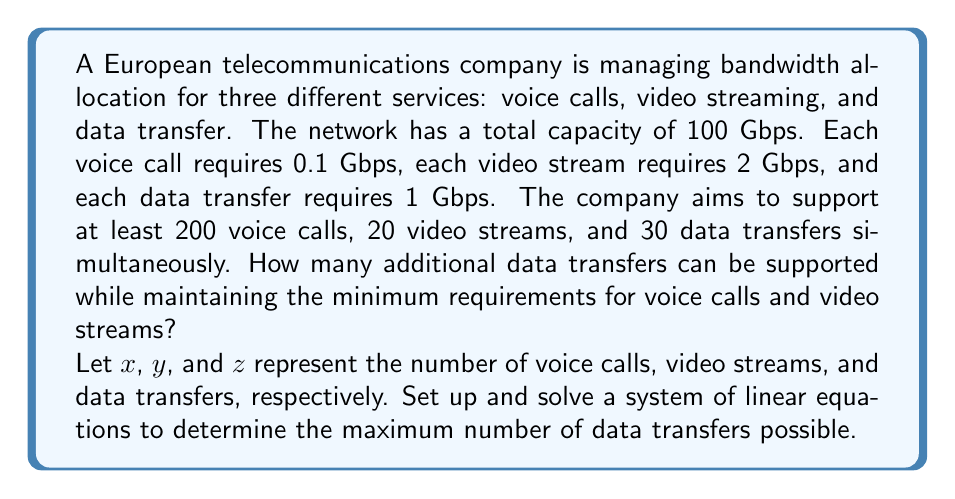Give your solution to this math problem. Let's approach this problem step-by-step:

1) First, we set up our system of linear equations based on the given information:

   $$0.1x + 2y + z \leq 100$$ (total bandwidth constraint)
   $$x \geq 200$$ (minimum voice calls)
   $$y \geq 20$$ (minimum video streams)
   $$z \geq 30$$ (minimum data transfers)

2) We want to maximize $z$, so let's start by setting $x$ and $y$ to their minimum values:
   
   $$x = 200$$
   $$y = 20$$

3) Substituting these into our bandwidth constraint equation:

   $$0.1(200) + 2(20) + z \leq 100$$
   $$20 + 40 + z \leq 100$$
   $$60 + z \leq 100$$
   $$z \leq 40$$

4) Since $z$ represents the number of data transfers and must be an integer, the maximum value for $z$ is 40.

5) We already have a minimum of 30 data transfers, so the additional number of data transfers that can be supported is:

   $$40 - 30 = 10$$

Therefore, 10 additional data transfers can be supported while maintaining the minimum requirements for voice calls and video streams.
Answer: 10 additional data transfers 